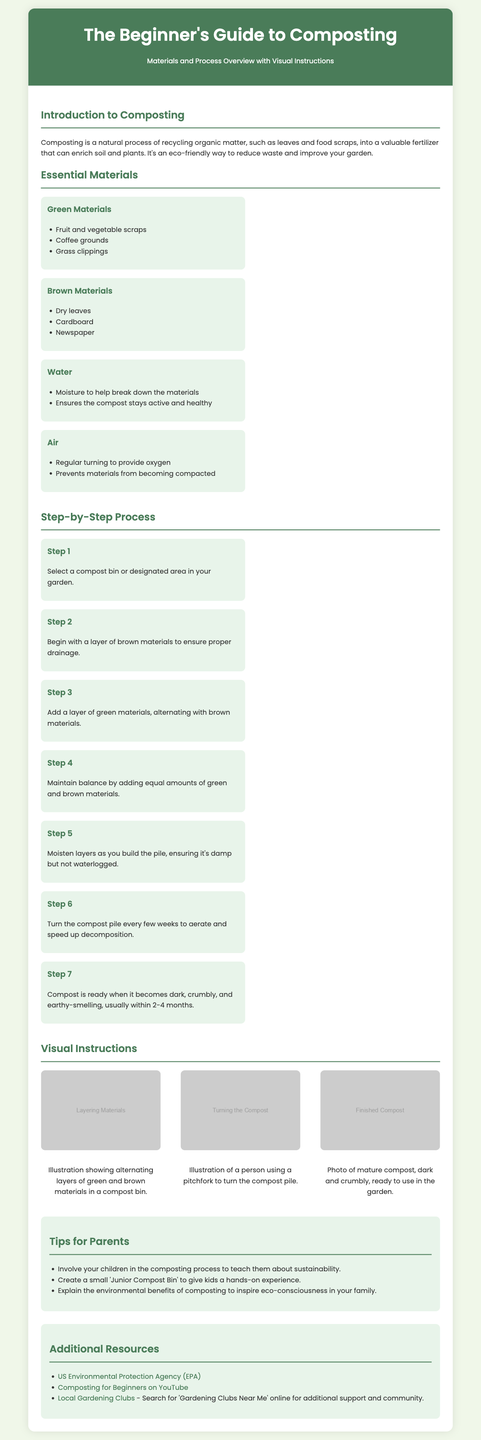What is composting? Composting is defined in the introduction as a natural process of recycling organic matter into a valuable fertilizer.
Answer: Recycling organic matter What are three examples of green materials? The document lists fruit and vegetable scraps, coffee grounds, and grass clippings as examples of green materials.
Answer: Fruit and vegetable scraps, coffee grounds, grass clippings How many steps are in the composting process? The document outlines a total of seven steps in the composting process.
Answer: Seven steps What is the purpose of water in the composting process? The document explains that water provides moisture to help break down the materials and keeps the compost active and healthy.
Answer: Helps break down materials What should you do every few weeks to maintain the compost? The process description mentions that you should turn the compost pile every few weeks to aerate it.
Answer: Turn the compost pile What is indicated as the readiness state of compost? The document states that compost is ready when it becomes dark, crumbly, and earthy-smelling.
Answer: Dark, crumbly, and earthy-smelling What kind of experience can you create for children according to the tips? The tips suggest creating a small 'Junior Compost Bin' to give kids a hands-on experience.
Answer: Junior Compost Bin Which organization offers additional information on composting? The document lists the US Environmental Protection Agency (EPA) as a resource for additional information.
Answer: US Environmental Protection Agency (EPA) 